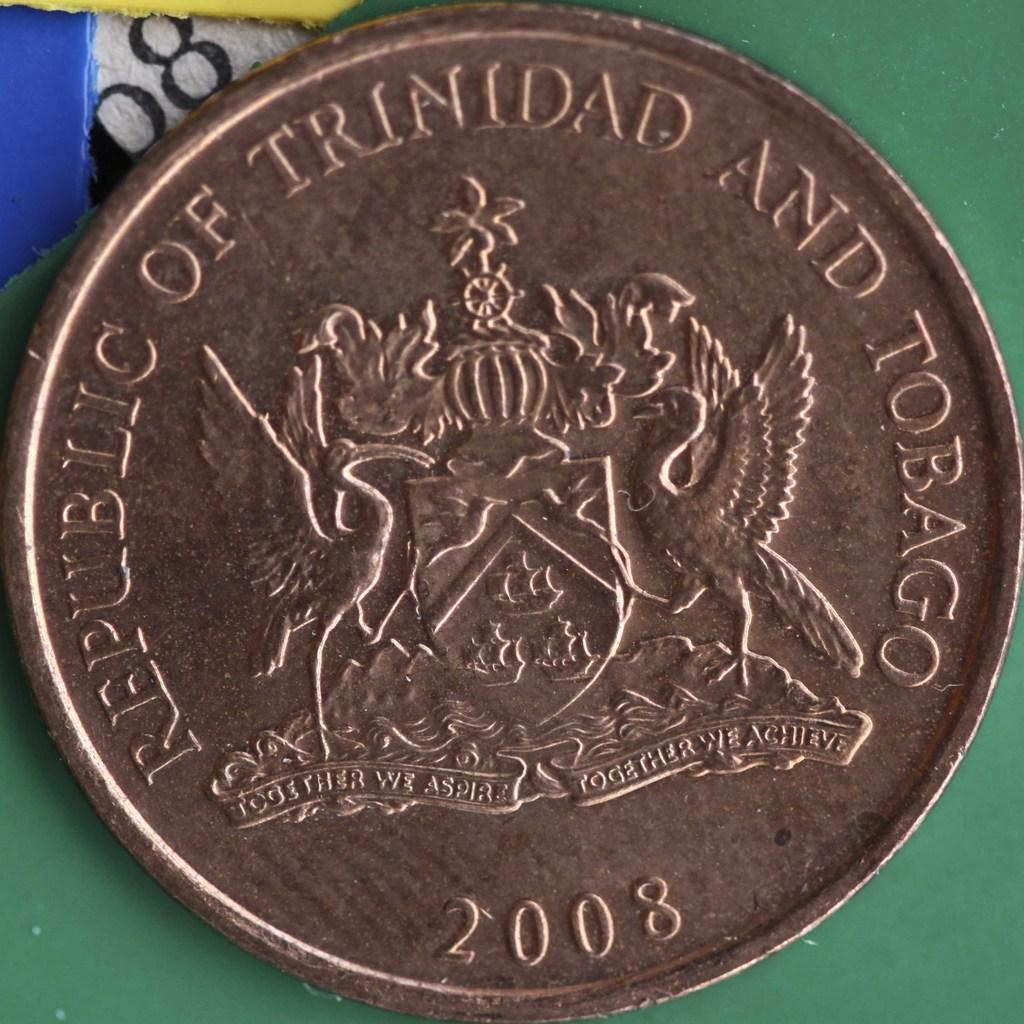<image>
Describe the image concisely. The bronze coin sitting on a green background was made in 2008. 